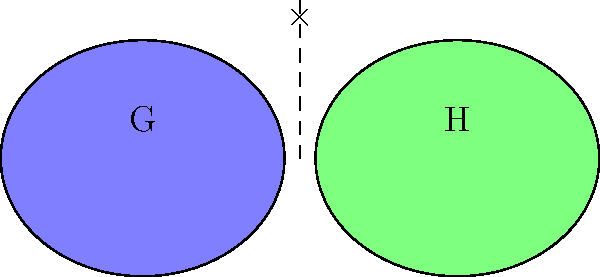Given two groups G and H represented by the Venn diagrams above, what is the order of the direct product G × H if |G| = 6 and |H| = 8? Provide the answer as an algebraic expression. To solve this problem efficiently, we need to apply the fundamental property of direct products:

1. Recall that for two groups G and H, the order of their direct product G × H is given by:
   $|G \times H| = |G| \cdot |H|$

2. We are given that:
   $|G| = 6$
   $|H| = 8$

3. Substituting these values into the formula:
   $|G \times H| = 6 \cdot 8$

4. Simplify:
   $|G \times H| = 48$

Therefore, the order of the direct product G × H is 48.
Answer: $6 \cdot 8$ 